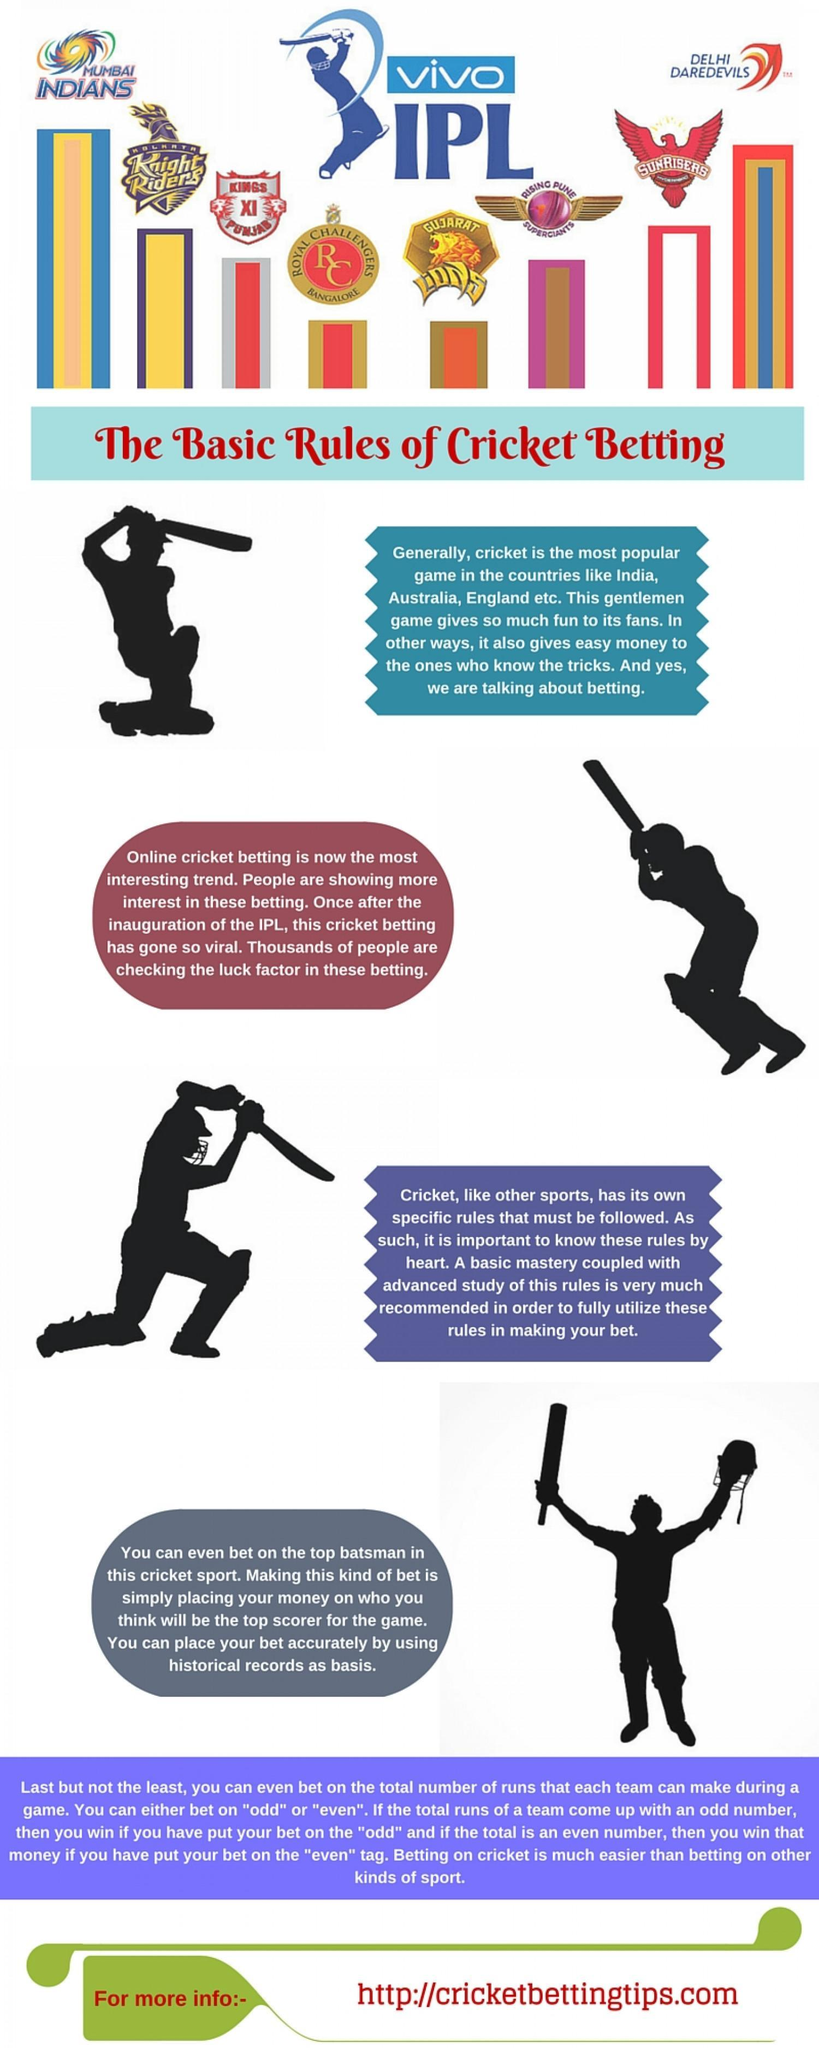How many IPL teams mentioned in this infographic?
Answer the question with a short phrase. 8 Which is the second IPL team mentioned in this infographic? Knight Riders 